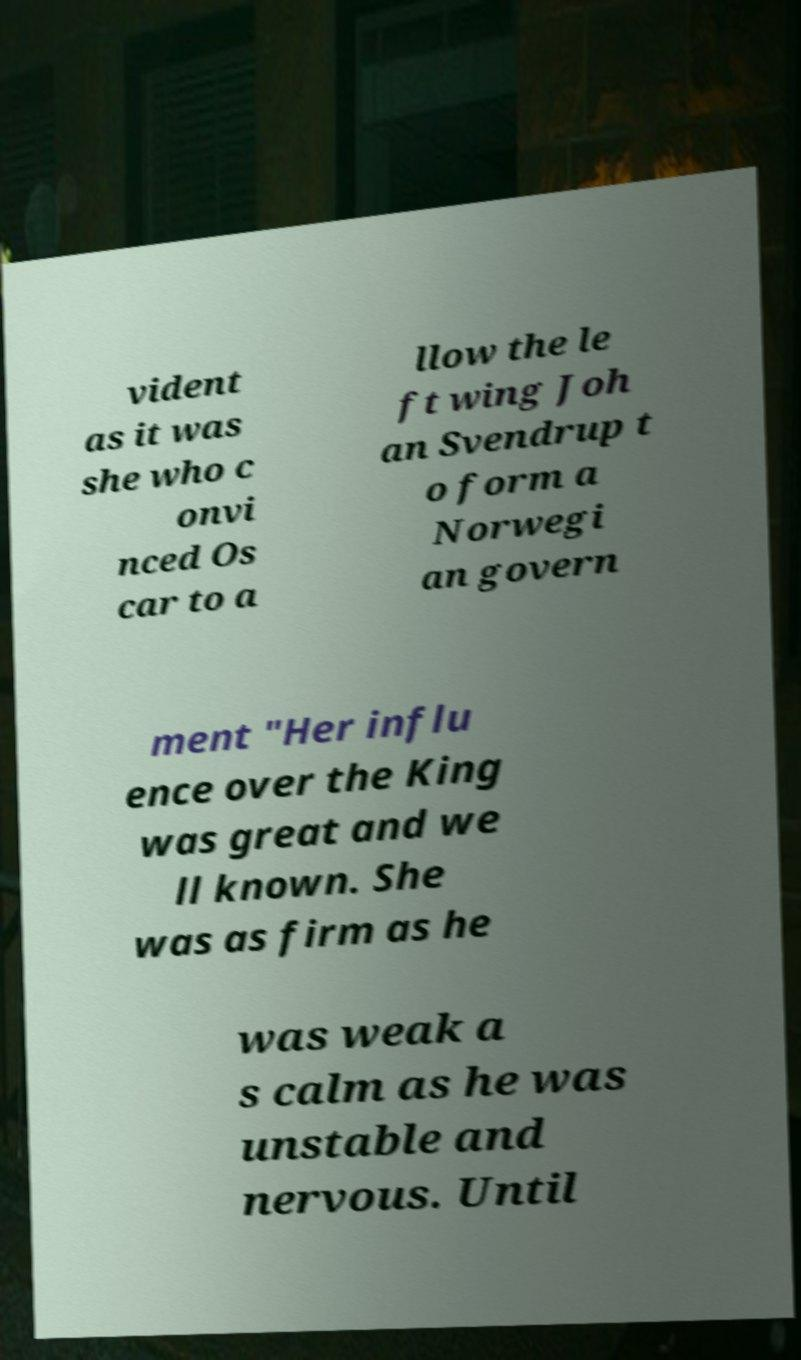Could you extract and type out the text from this image? vident as it was she who c onvi nced Os car to a llow the le ft wing Joh an Svendrup t o form a Norwegi an govern ment "Her influ ence over the King was great and we ll known. She was as firm as he was weak a s calm as he was unstable and nervous. Until 